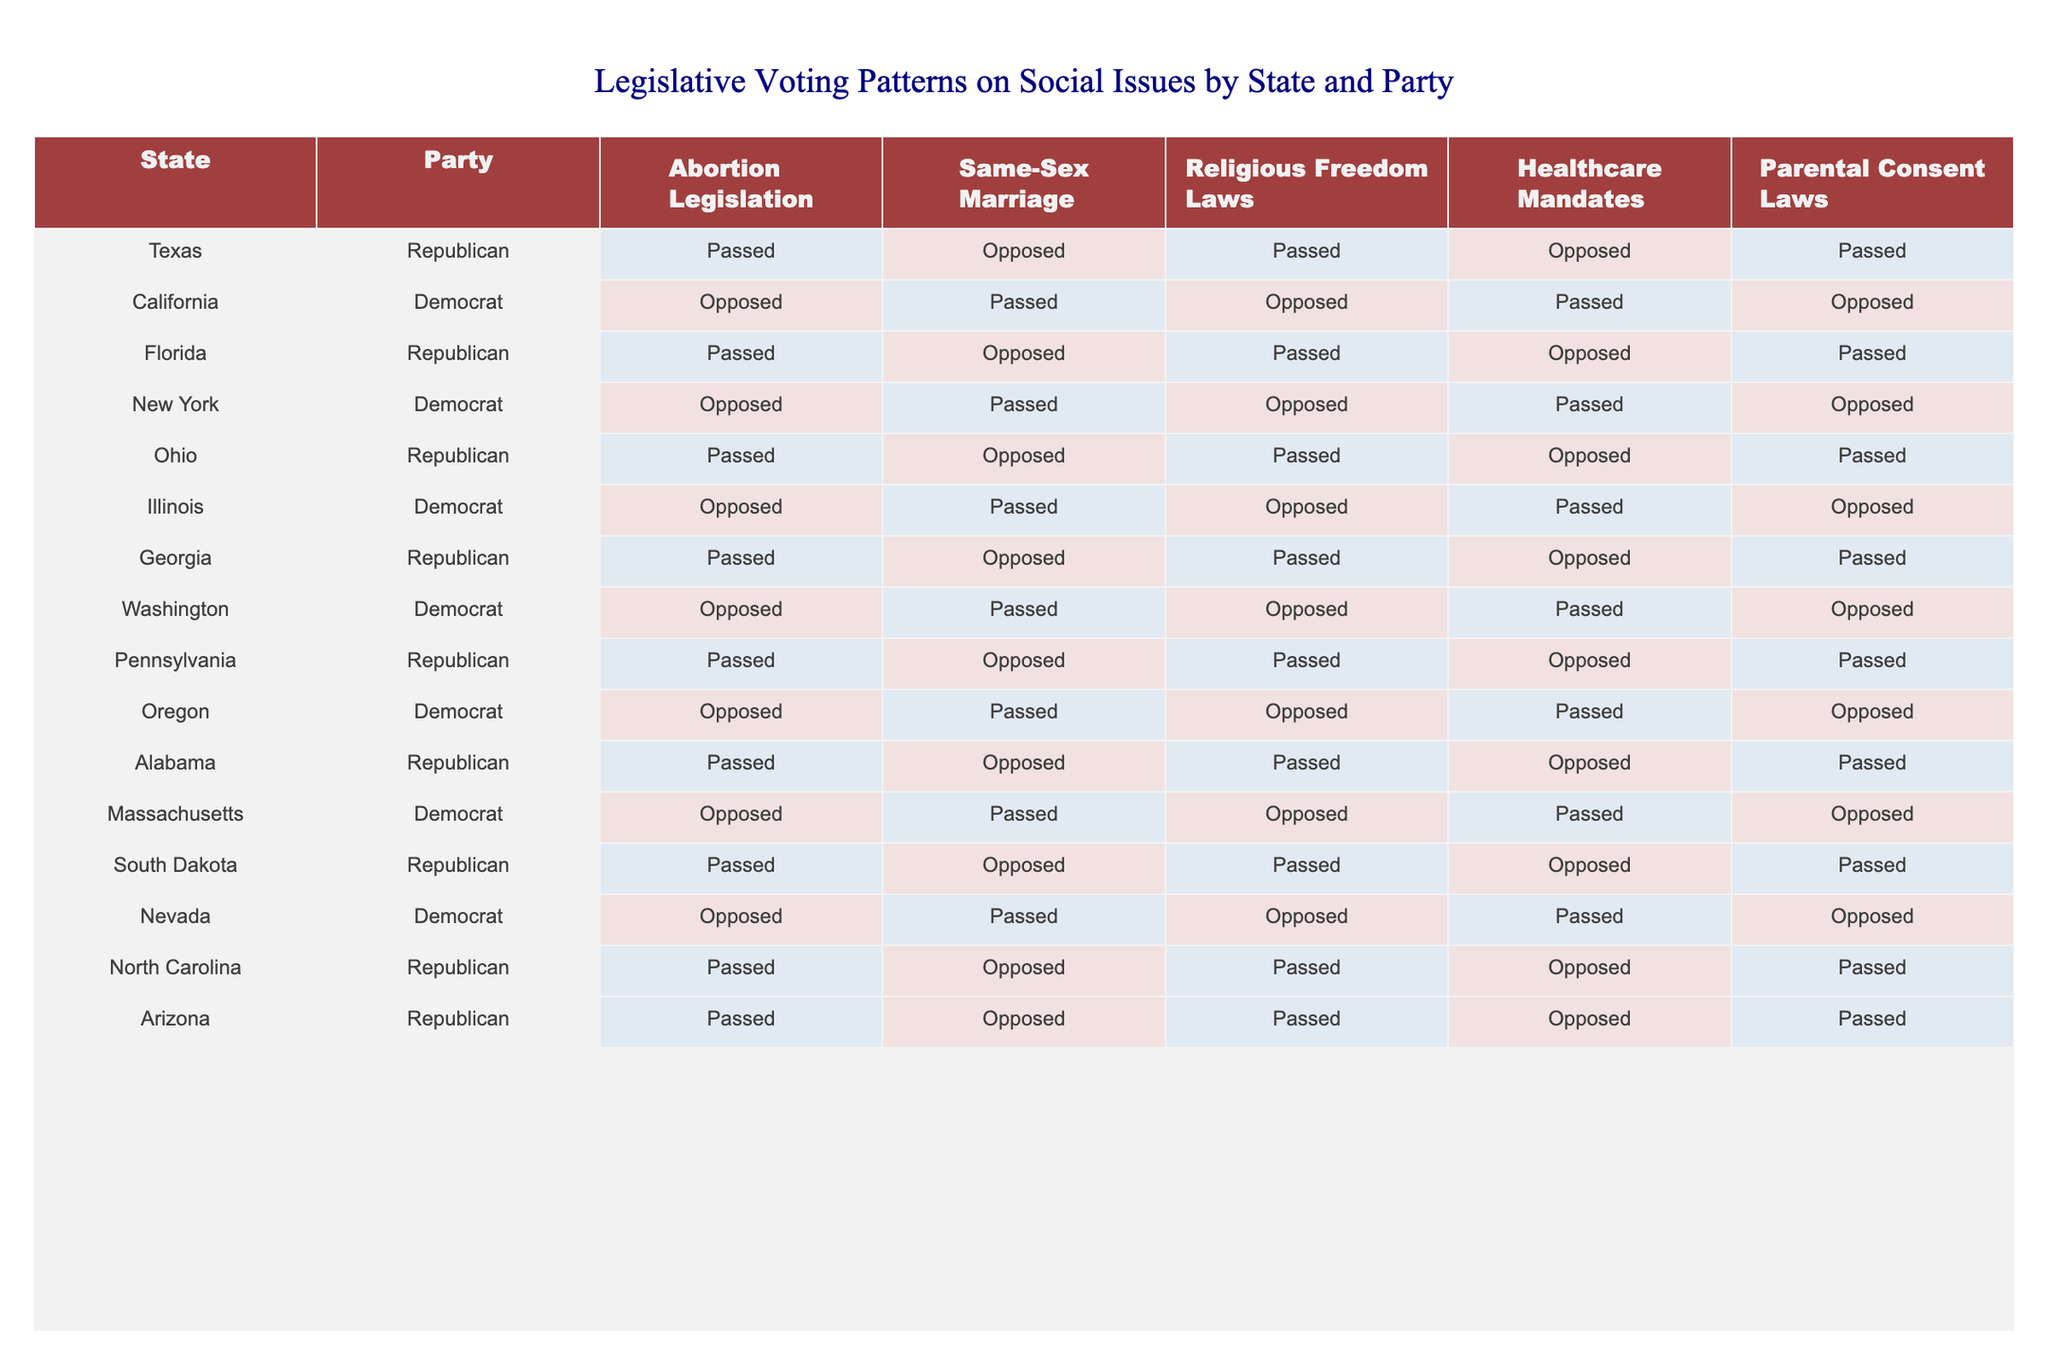What percentage of Republican states passed Religious Freedom Laws? There are 10 states in total, and all Republican states (Texas, Florida, Ohio, Georgia, Pennsylvania, Alabama, South Dakota, North Carolina, Arizona) passed Religious Freedom Laws, so 9 out of 9 Republican states passed this law. To find the percentage: (9/9) * 100 = 100%.
Answer: 100% Which state among the Democrats opposed Abortion Legislation? When reviewing the Democratic states (California, New York, Illinois, Oregon, Massachusetts, Nevada), it's clear that all of them opposed Abortion Legislation. Thus, any state counts, but referencing one, California is mentioned here.
Answer: California How many states passed both Parental Consent Laws and Healthcare Mandates? In the table, we see that Texas, Florida, Ohio, Georgia, Pennsylvania, Alabama, South Dakota, North Carolina, and Arizona (9 states) passed Parental Consent Laws, and all these states also opposed Healthcare Mandates (2 Democrat states) which makes this a combined count of 9.  Thus, the total count is 9 states.
Answer: 9 states Is there a state where both Abortion Legislation and Same-Sex Marriage were passed? Reviewing the table, all states maintain a consistent position on Abortion Legislation, with Republicans passing, while Democrats oppose. However, for Same-Sex Marriage, only Democratic states have passed them. Therefore, there are no states where both conditions are satisfied.
Answer: No What can be inferred about Republican and Democrat trends concerning same-sex marriage legislation? From the table, we observe that all Republican states opposed Same-Sex Marriage, whereas all Democratic states passed it. This indicates a clear partisan divide where Republicans are against and Democrats support Same-Sex Marriage legislation.
Answer: Clear partisan divide How do Democratic states compare in their approach to Healthcare Mandates versus Parental Consent Laws? None of the Democratic states passed Parental Consent Laws, while they all passed Healthcare Mandates. This shows that Democrats focus more on Healthcare Mandates without endorsing Parental Consent Laws, highlighting their legislative priorities.
Answer: Democrats endorse Healthcare Mandates Which political party has consistent support for Religious Freedom Laws across all its states? Looking at the table, the Republican Party shows consistent support as every Republican state has passed Religious Freedom Laws whereas the Democrats have a mix of opposition. Thus, we conclude that the Republican Party has consistent support.
Answer: Republican Party How many states opposed Same-Sex Marriage in total? When aggregating the data, we note that all Republican states opposed Same-Sex Marriage (10 total) while all Democrat states passed it (6 total). Thus, the total number of states opposing this legislation is 10.
Answer: 10 states 